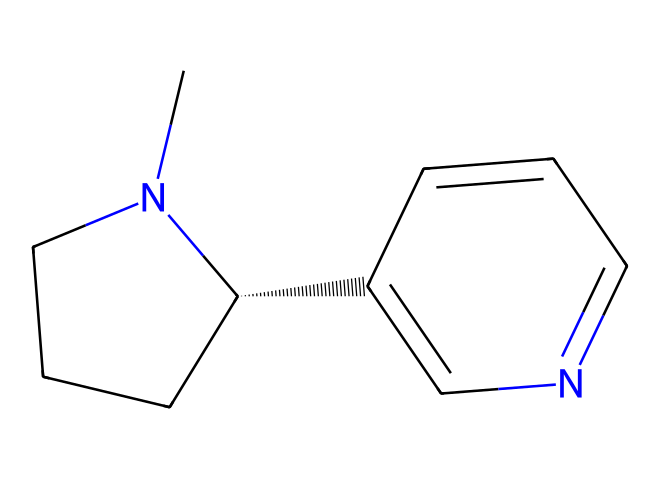What is the molecular formula of nicotine? To derive the molecular formula, we analyze the SMILES representation, noting the types and counts of atoms. The structure consists of 10 carbon (C) atoms, 14 hydrogen (H) atoms, and 2 nitrogen (N) atoms; thus, the molecular formula is C10H14N2.
Answer: C10H14N2 How many rings are present in the structure of nicotine? By examining the SMILES string, we look for numerical annotations that indicate ring closures, specifically the '1' and '2' which denote ring formations. This chemical has two ring structures, indicated by these annotations.
Answer: 2 What functional group is present in nicotine? Considering the structure, nicotine contains nitrogen atoms that are part of a basic alkaloid structure. The presence of these nitrogen atoms within the cyclic and acyclic part confirms that it exhibits amine characteristics, which is characteristic of alkaloids.
Answer: amine How does the structure indicate nicotine's classification as an alkaloid? Alkaloids are characterized by the presence of basic nitrogen atoms, typically within a heterocyclic structure. In nicotine, nitrogen is embedded within a ring structure (indicated by cyclic connections) and contributes to its pharmacological properties, confirming its classification as an alkaloid.
Answer: heterocyclic nitrogen What is the total number of nitrogen atoms in this chemical? By inspecting the SMILES representation, we identify two nitrogen atoms present in the structure of nicotine. Thus, the total count of nitrogen atoms can be easily deduced from the visual analysis.
Answer: 2 What property of nicotine's structure contributes to its addictive nature? The presence of nitrogen atoms within a cyclic structure enhances its interaction with neurotransmitter receptors in the brain, contributing significantly to nicotine's addictive properties. This pharmacological effect is primarily driven by the nitrogen presence.
Answer: nitrogen What is the significance of the chiral center in the nicotine molecule? The chiral center in nicotine (indicated by the '@' symbol in the SMILES) refers to the carbon atom that is bonded to four different substituents, leading to two enantiomers. This configuration is crucial as it influences nicotine's biological activity and its recognition by different receptors in the body.
Answer: biological activity 